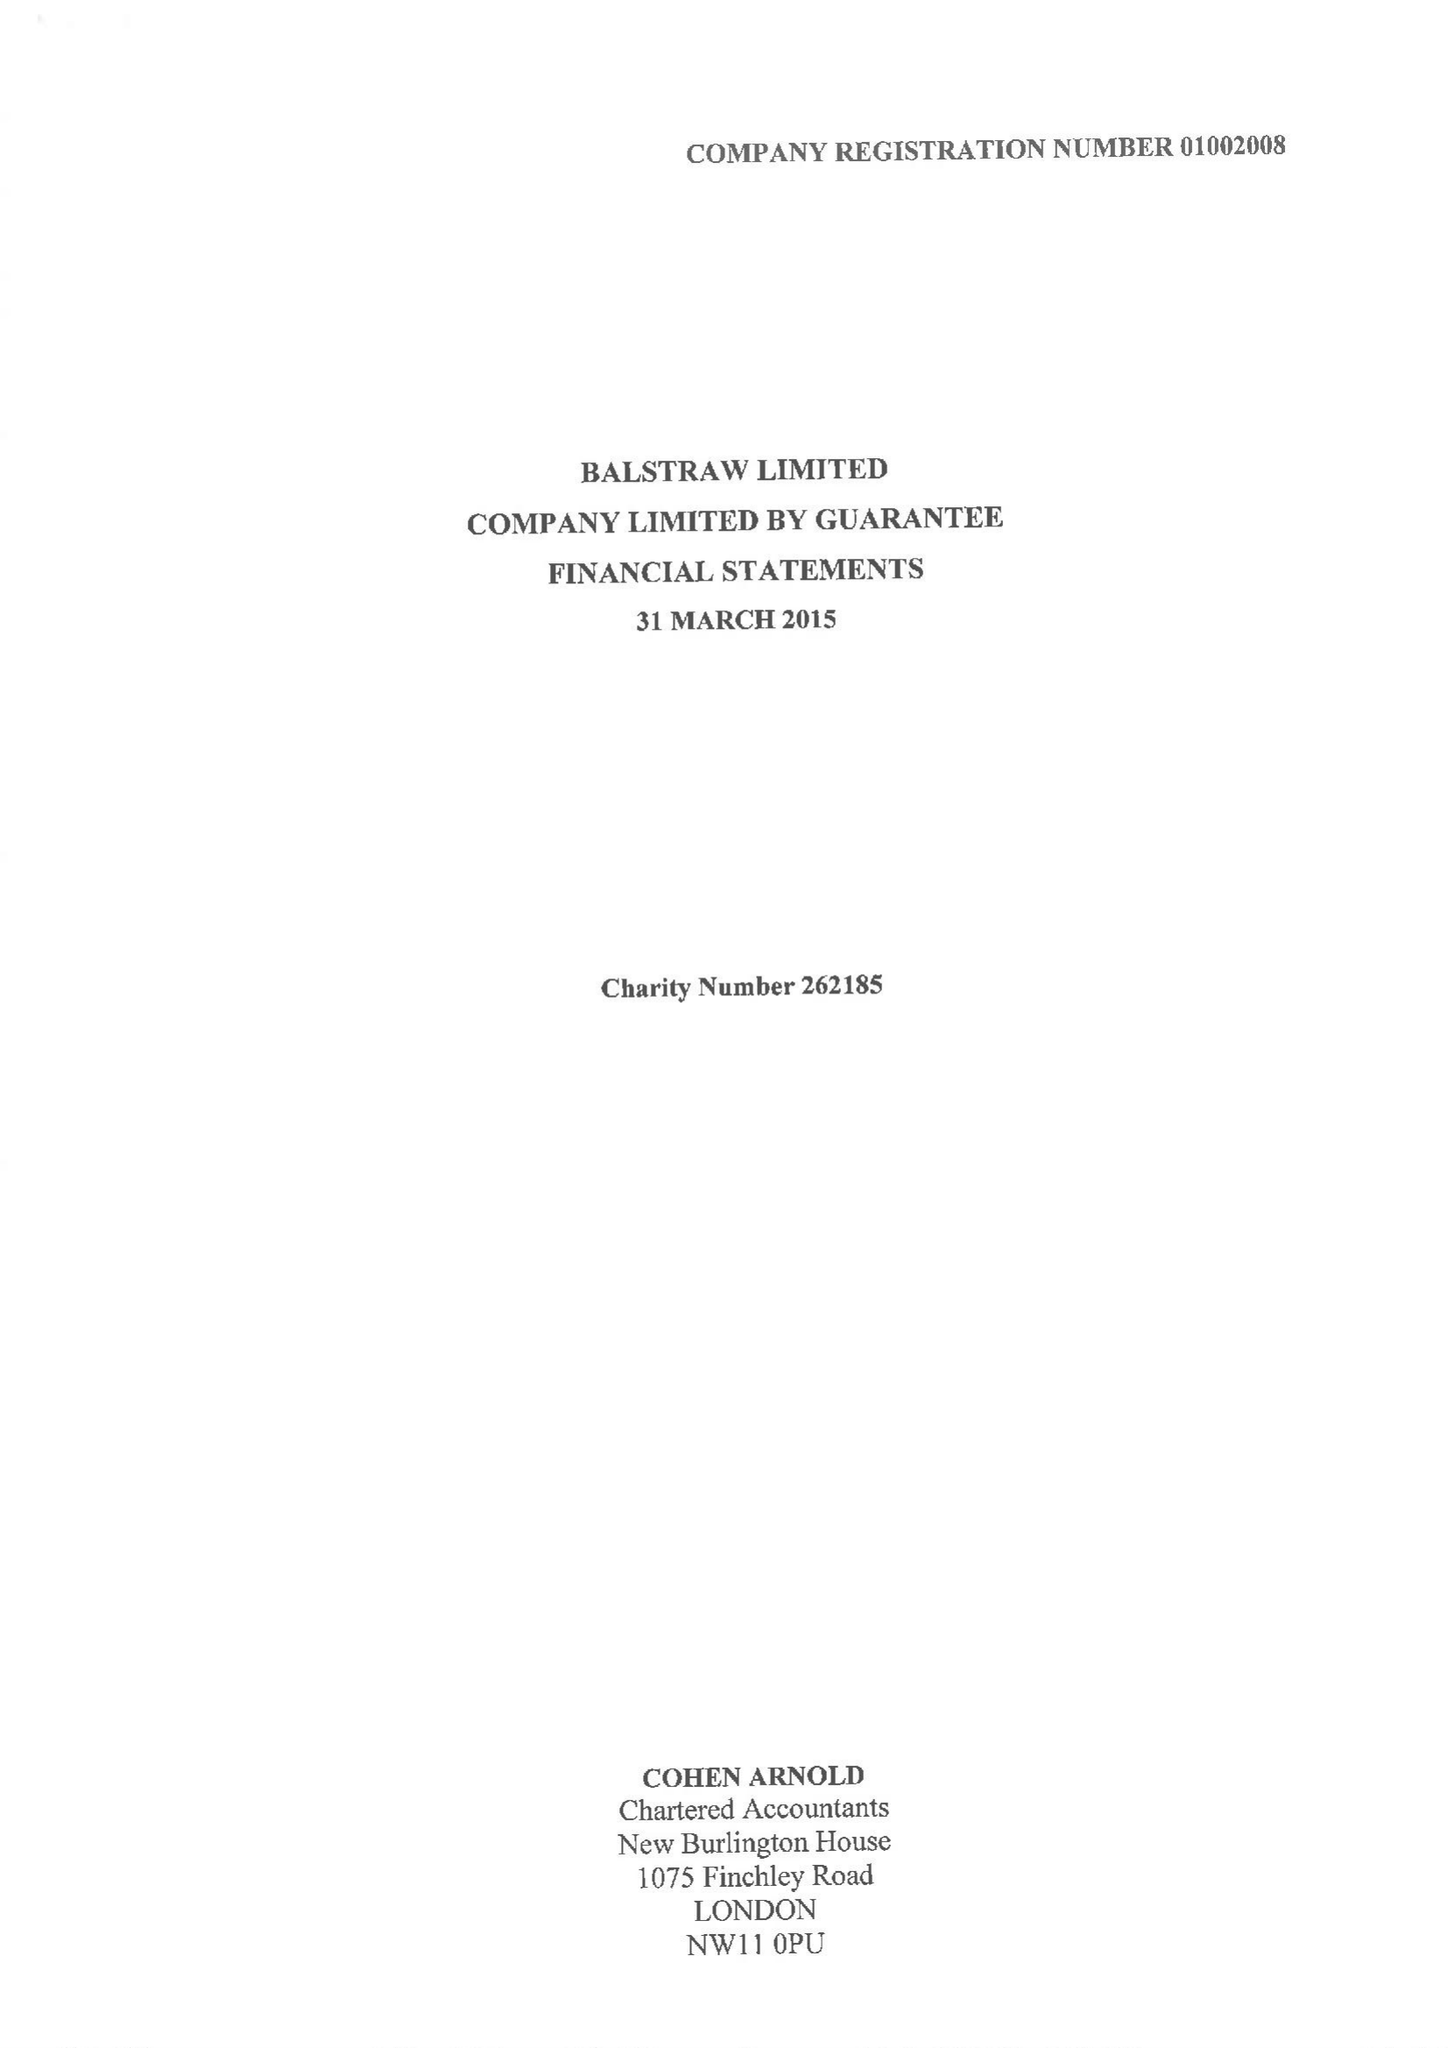What is the value for the charity_name?
Answer the question using a single word or phrase. Balstraw Ltd. 